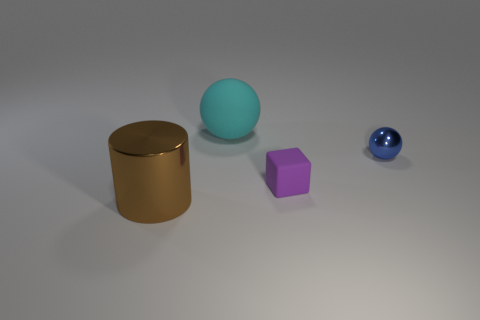Add 4 brown matte things. How many objects exist? 8 Add 1 cyan rubber spheres. How many cyan rubber spheres are left? 2 Add 4 red shiny objects. How many red shiny objects exist? 4 Subtract 1 purple cubes. How many objects are left? 3 Subtract all big gray blocks. Subtract all shiny cylinders. How many objects are left? 3 